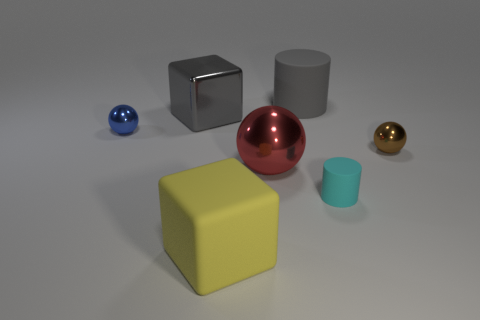What number of other large things have the same shape as the gray matte object?
Ensure brevity in your answer.  0. What is the size of the cube that is behind the large red object that is right of the small shiny object on the left side of the brown shiny thing?
Offer a terse response. Large. What number of gray things are either tiny spheres or shiny cubes?
Offer a terse response. 1. There is a tiny shiny object that is on the left side of the big yellow object; is its shape the same as the big yellow object?
Keep it short and to the point. No. Are there more yellow cubes left of the big gray cube than large shiny objects?
Your answer should be compact. No. How many red shiny things have the same size as the yellow rubber cube?
Offer a very short reply. 1. There is a rubber cylinder that is the same color as the large metal block; what size is it?
Ensure brevity in your answer.  Large. How many objects are either large yellow matte blocks or balls behind the red shiny object?
Your response must be concise. 3. What color is the tiny object that is behind the tiny cyan thing and left of the tiny brown thing?
Provide a short and direct response. Blue. Is the brown object the same size as the yellow block?
Make the answer very short. No. 